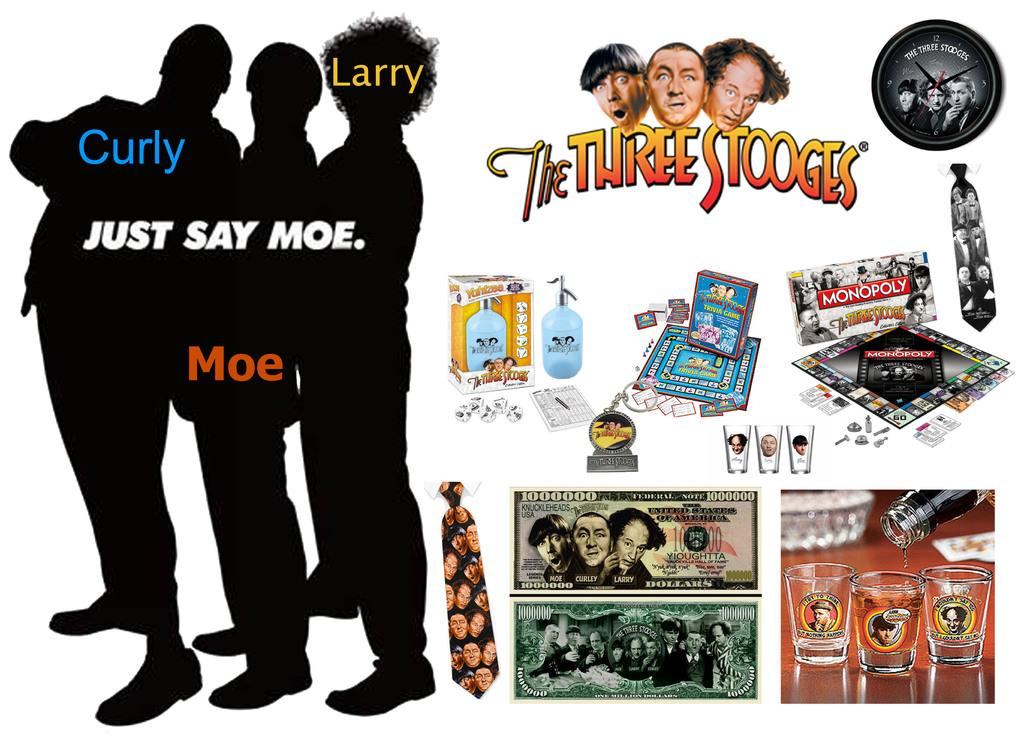<image>
Describe the image concisely. All Three Stooges memorabilia including Curly, Larry, and Moe. 